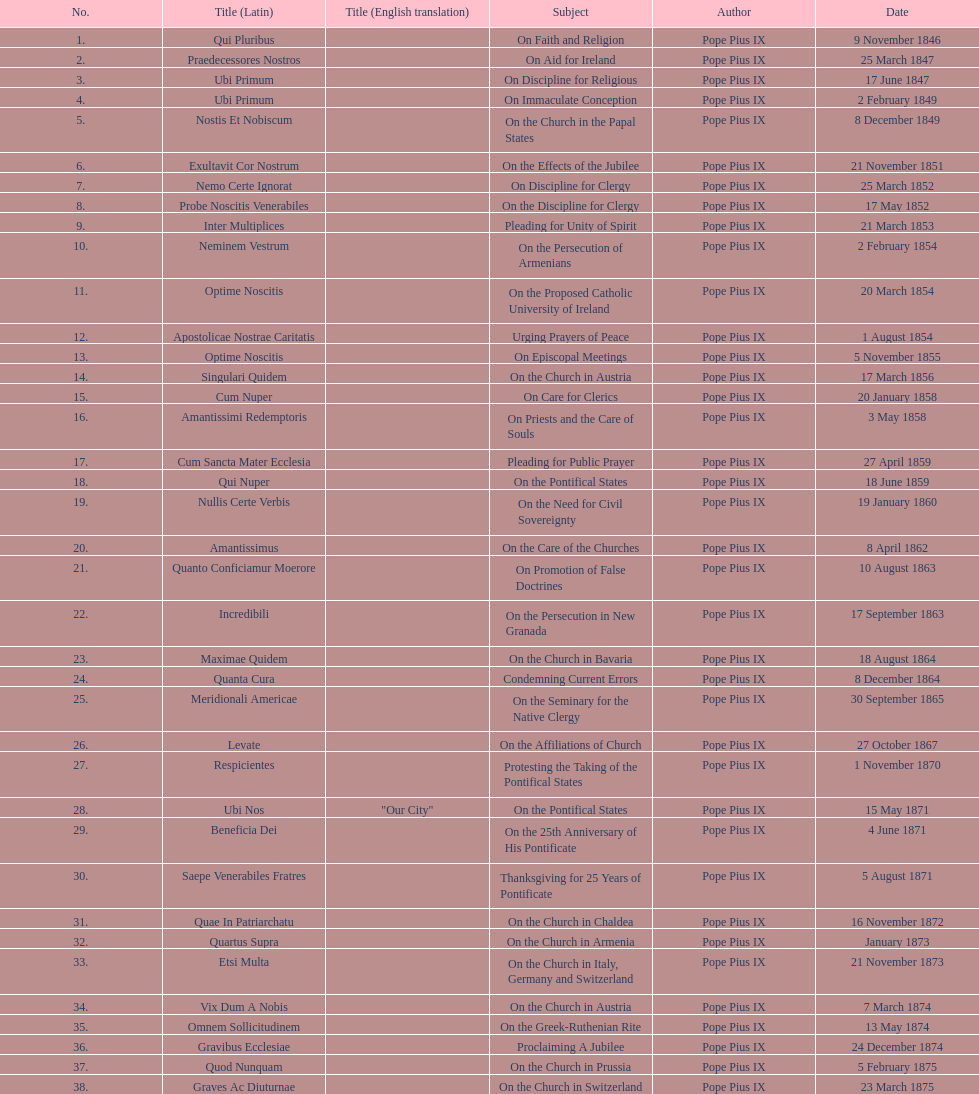What is the last title? Graves Ac Diuturnae. 